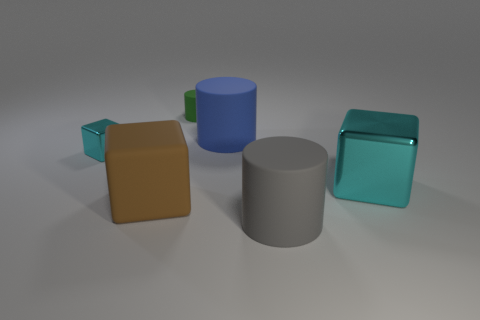Add 1 rubber objects. How many objects exist? 7 Add 4 large gray rubber cylinders. How many large gray rubber cylinders exist? 5 Subtract 0 green spheres. How many objects are left? 6 Subtract all big cyan metal cubes. Subtract all yellow matte cubes. How many objects are left? 5 Add 5 big blue cylinders. How many big blue cylinders are left? 6 